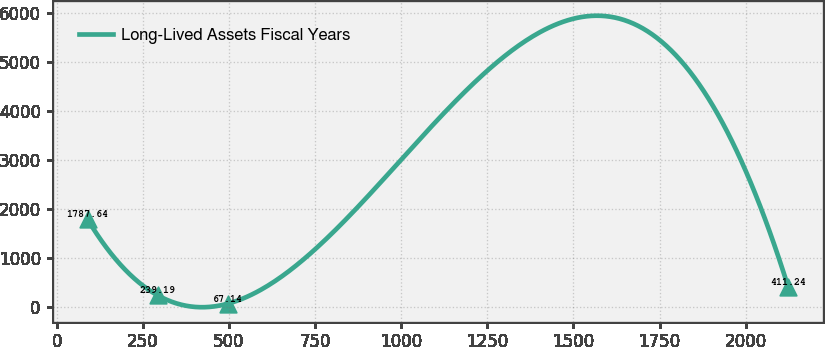<chart> <loc_0><loc_0><loc_500><loc_500><line_chart><ecel><fcel>Long-Lived Assets Fiscal Years<nl><fcel>89.4<fcel>1787.64<nl><fcel>292.81<fcel>239.19<nl><fcel>496.22<fcel>67.14<nl><fcel>2123.48<fcel>411.24<nl></chart> 